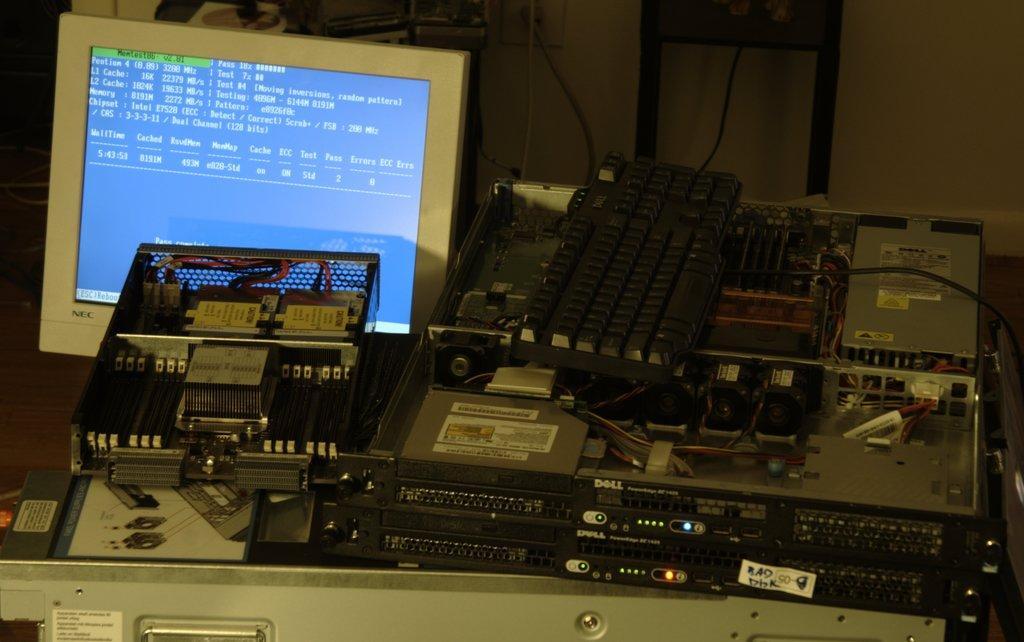In one or two sentences, can you explain what this image depicts? In this image I can see sound boxes, keyboard, circuit and a PC on the table. In the background I can see a wall, books and wires. This image is taken in a room. 